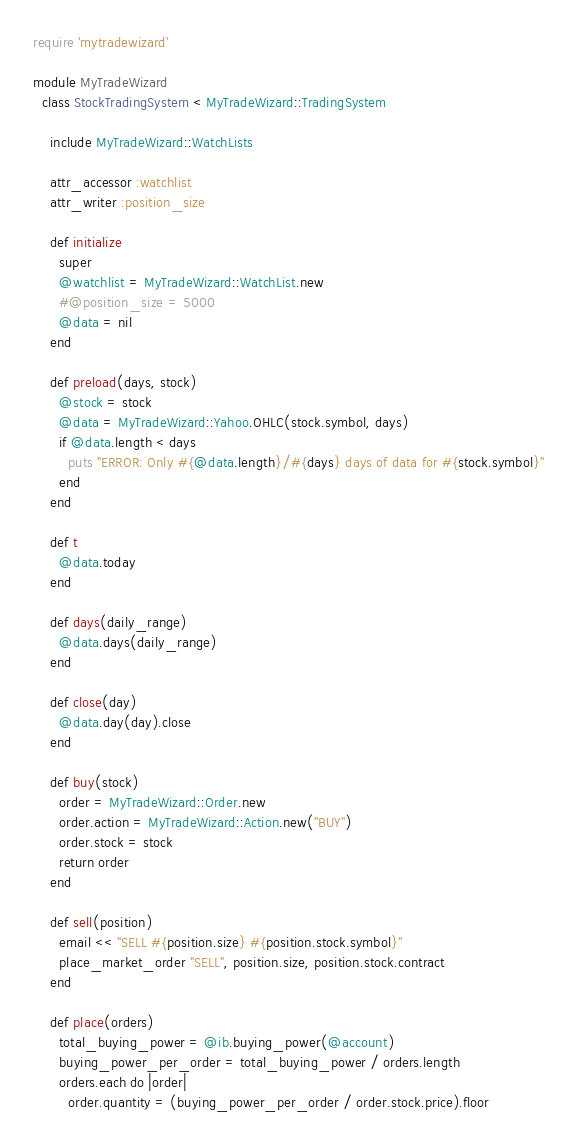Convert code to text. <code><loc_0><loc_0><loc_500><loc_500><_Ruby_>require 'mytradewizard'

module MyTradeWizard
  class StockTradingSystem < MyTradeWizard::TradingSystem

    include MyTradeWizard::WatchLists

    attr_accessor :watchlist
    attr_writer :position_size

    def initialize
      super
      @watchlist = MyTradeWizard::WatchList.new
      #@position_size = 5000
      @data = nil
    end

    def preload(days, stock)
      @stock = stock
      @data = MyTradeWizard::Yahoo.OHLC(stock.symbol, days)
      if @data.length < days
        puts "ERROR: Only #{@data.length}/#{days} days of data for #{stock.symbol}"
      end
    end

    def t
      @data.today
    end

    def days(daily_range)
      @data.days(daily_range)
    end

    def close(day)
      @data.day(day).close
    end

    def buy(stock)
      order = MyTradeWizard::Order.new
      order.action = MyTradeWizard::Action.new("BUY")
      order.stock = stock
      return order
    end

    def sell(position)
      email << "SELL #{position.size} #{position.stock.symbol}"
      place_market_order "SELL", position.size, position.stock.contract
    end

    def place(orders)
      total_buying_power = @ib.buying_power(@account)
      buying_power_per_order = total_buying_power / orders.length
      orders.each do |order|
        order.quantity = (buying_power_per_order / order.stock.price).floor</code> 